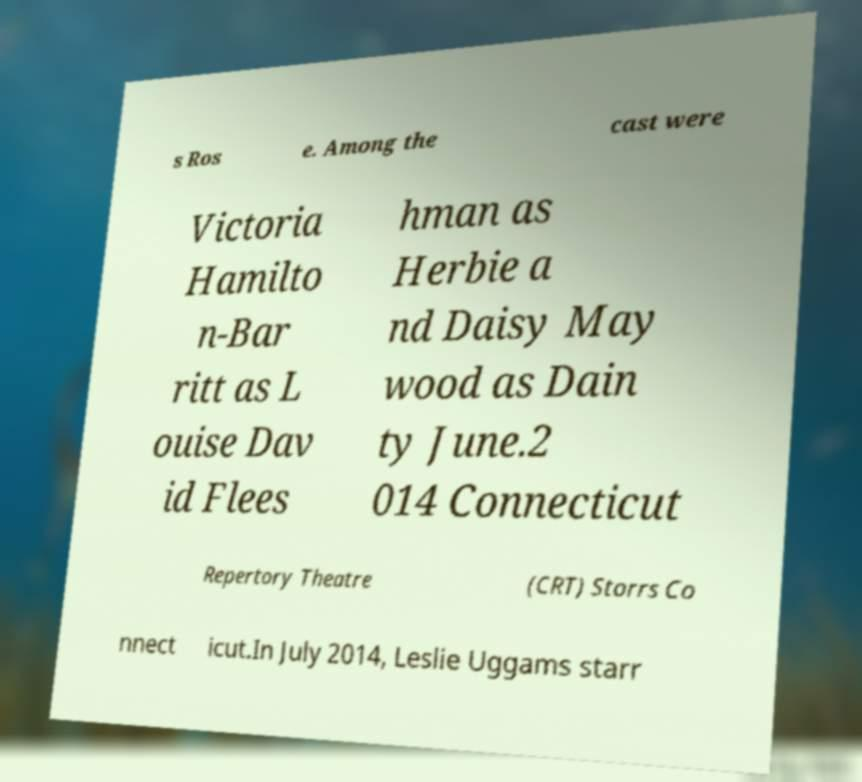There's text embedded in this image that I need extracted. Can you transcribe it verbatim? s Ros e. Among the cast were Victoria Hamilto n-Bar ritt as L ouise Dav id Flees hman as Herbie a nd Daisy May wood as Dain ty June.2 014 Connecticut Repertory Theatre (CRT) Storrs Co nnect icut.In July 2014, Leslie Uggams starr 